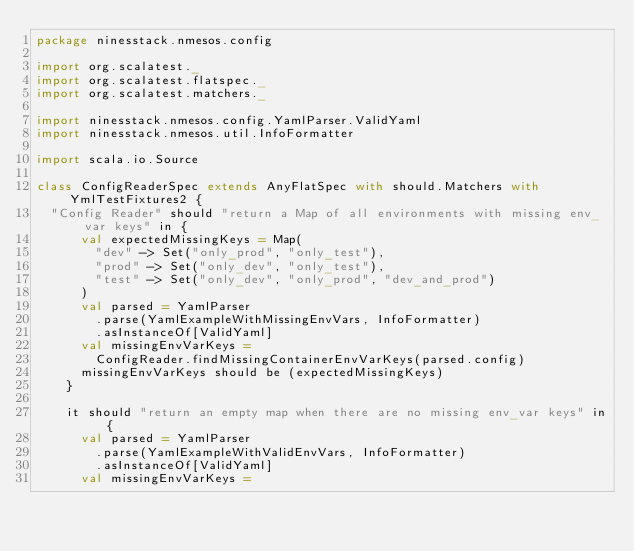Convert code to text. <code><loc_0><loc_0><loc_500><loc_500><_Scala_>package ninesstack.nmesos.config

import org.scalatest._
import org.scalatest.flatspec._
import org.scalatest.matchers._

import ninesstack.nmesos.config.YamlParser.ValidYaml
import ninesstack.nmesos.util.InfoFormatter

import scala.io.Source

class ConfigReaderSpec extends AnyFlatSpec with should.Matchers with YmlTestFixtures2 {
  "Config Reader" should "return a Map of all environments with missing env_var keys" in {
      val expectedMissingKeys = Map(
        "dev" -> Set("only_prod", "only_test"),
        "prod" -> Set("only_dev", "only_test"),
        "test" -> Set("only_dev", "only_prod", "dev_and_prod")
      )
      val parsed = YamlParser
        .parse(YamlExampleWithMissingEnvVars, InfoFormatter)
        .asInstanceOf[ValidYaml]
      val missingEnvVarKeys =
        ConfigReader.findMissingContainerEnvVarKeys(parsed.config)
      missingEnvVarKeys should be (expectedMissingKeys)
    }

    it should "return an empty map when there are no missing env_var keys" in {
      val parsed = YamlParser
        .parse(YamlExampleWithValidEnvVars, InfoFormatter)
        .asInstanceOf[ValidYaml]
      val missingEnvVarKeys =</code> 